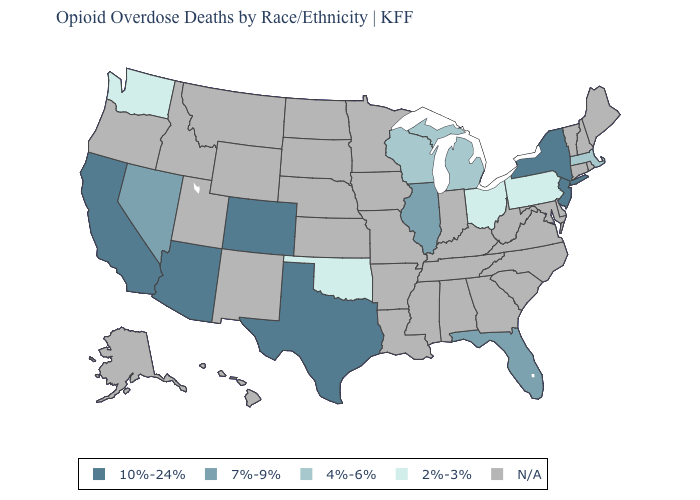Does Oklahoma have the highest value in the South?
Answer briefly. No. Which states have the lowest value in the MidWest?
Short answer required. Ohio. Name the states that have a value in the range 10%-24%?
Concise answer only. Arizona, California, Colorado, New Jersey, New York, Texas. Among the states that border Iowa , does Wisconsin have the highest value?
Quick response, please. No. What is the value of Alabama?
Answer briefly. N/A. What is the value of Idaho?
Give a very brief answer. N/A. Does Oklahoma have the highest value in the South?
Concise answer only. No. Name the states that have a value in the range 10%-24%?
Write a very short answer. Arizona, California, Colorado, New Jersey, New York, Texas. Name the states that have a value in the range 2%-3%?
Concise answer only. Ohio, Oklahoma, Pennsylvania, Washington. Among the states that border Wisconsin , which have the highest value?
Quick response, please. Illinois. What is the value of Alabama?
Give a very brief answer. N/A. Does Texas have the highest value in the South?
Answer briefly. Yes. Which states have the highest value in the USA?
Be succinct. Arizona, California, Colorado, New Jersey, New York, Texas. What is the lowest value in the USA?
Quick response, please. 2%-3%. What is the value of Illinois?
Answer briefly. 7%-9%. 